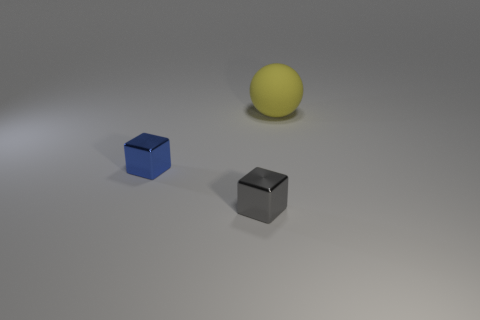There is a object that is the same size as the gray block; what color is it?
Give a very brief answer. Blue. How many large things are either spheres or yellow metallic cylinders?
Your response must be concise. 1. What material is the object that is to the right of the tiny blue metallic object and in front of the big rubber thing?
Ensure brevity in your answer.  Metal. There is a tiny shiny object to the left of the gray cube; is it the same shape as the yellow thing right of the gray shiny block?
Offer a terse response. No. How many objects are either spheres that are to the right of the blue metallic object or shiny cubes?
Your response must be concise. 3. Is the size of the yellow matte thing the same as the gray shiny object?
Provide a short and direct response. No. There is a shiny thing that is in front of the tiny blue cube; what is its color?
Provide a short and direct response. Gray. There is a object that is made of the same material as the tiny blue cube; what is its size?
Offer a very short reply. Small. There is a blue block; is its size the same as the cube that is in front of the tiny blue shiny block?
Give a very brief answer. Yes. What is the material of the tiny object that is on the left side of the tiny gray metal thing?
Provide a short and direct response. Metal. 